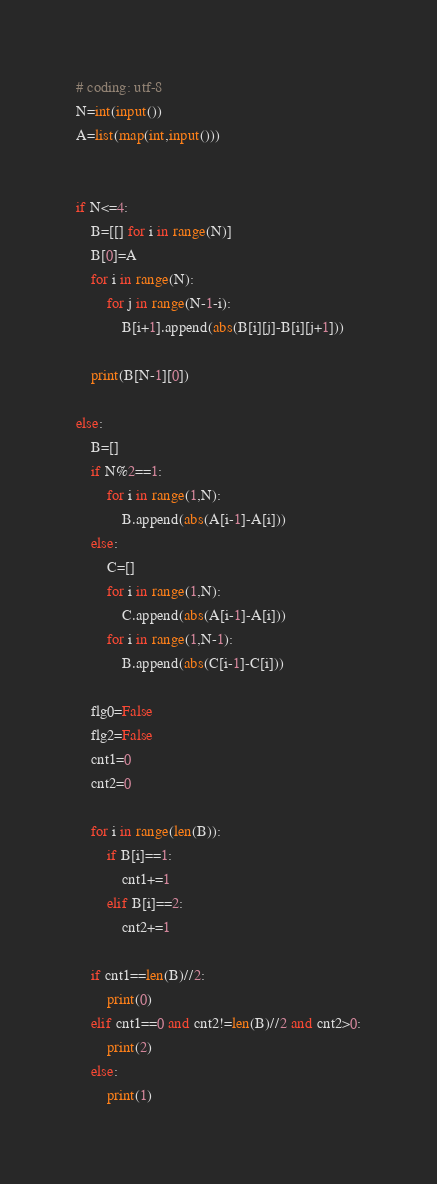Convert code to text. <code><loc_0><loc_0><loc_500><loc_500><_Python_># coding: utf-8
N=int(input())
A=list(map(int,input()))


if N<=4:
    B=[[] for i in range(N)]
    B[0]=A
    for i in range(N):
        for j in range(N-1-i):
            B[i+1].append(abs(B[i][j]-B[i][j+1]))
    
    print(B[N-1][0])
    
else:
    B=[]
    if N%2==1:
        for i in range(1,N):
            B.append(abs(A[i-1]-A[i]))
    else:
        C=[]
        for i in range(1,N):
            C.append(abs(A[i-1]-A[i]))
        for i in range(1,N-1):
            B.append(abs(C[i-1]-C[i]))
    
    flg0=False
    flg2=False
    cnt1=0
    cnt2=0
    
    for i in range(len(B)):
        if B[i]==1:
            cnt1+=1
        elif B[i]==2:
            cnt2+=1
    
    if cnt1==len(B)//2:
        print(0)
    elif cnt1==0 and cnt2!=len(B)//2 and cnt2>0:
        print(2)
    else:
        print(1)
</code> 